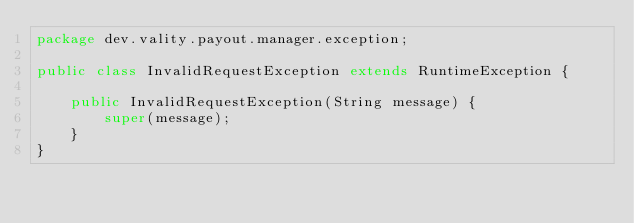<code> <loc_0><loc_0><loc_500><loc_500><_Java_>package dev.vality.payout.manager.exception;

public class InvalidRequestException extends RuntimeException {

    public InvalidRequestException(String message) {
        super(message);
    }
}
</code> 